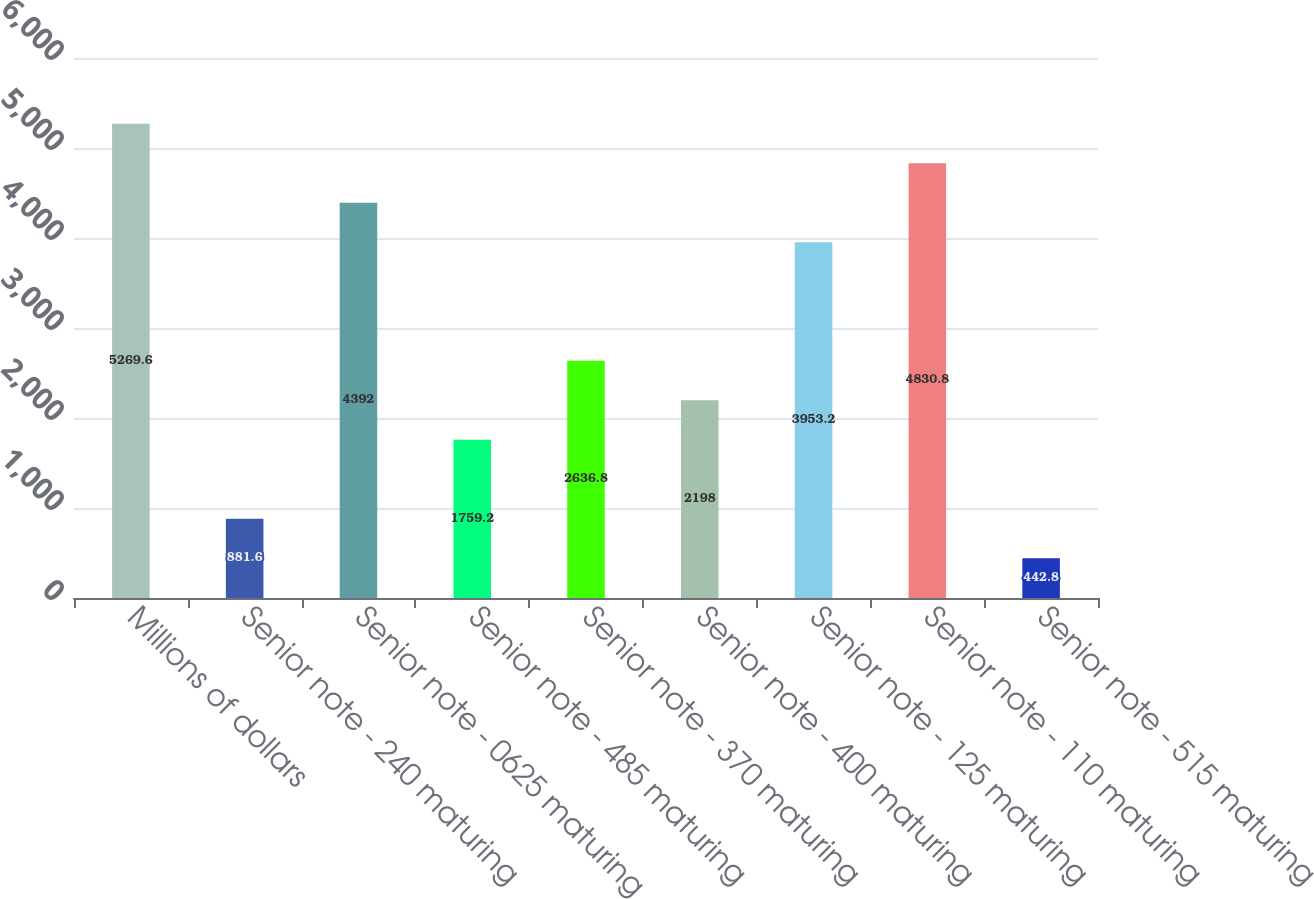Convert chart to OTSL. <chart><loc_0><loc_0><loc_500><loc_500><bar_chart><fcel>Millions of dollars<fcel>Senior note - 240 maturing<fcel>Senior note - 0625 maturing<fcel>Senior note - 485 maturing<fcel>Senior note - 370 maturing<fcel>Senior note - 400 maturing<fcel>Senior note - 125 maturing<fcel>Senior note - 110 maturing<fcel>Senior note - 515 maturing<nl><fcel>5269.6<fcel>881.6<fcel>4392<fcel>1759.2<fcel>2636.8<fcel>2198<fcel>3953.2<fcel>4830.8<fcel>442.8<nl></chart> 